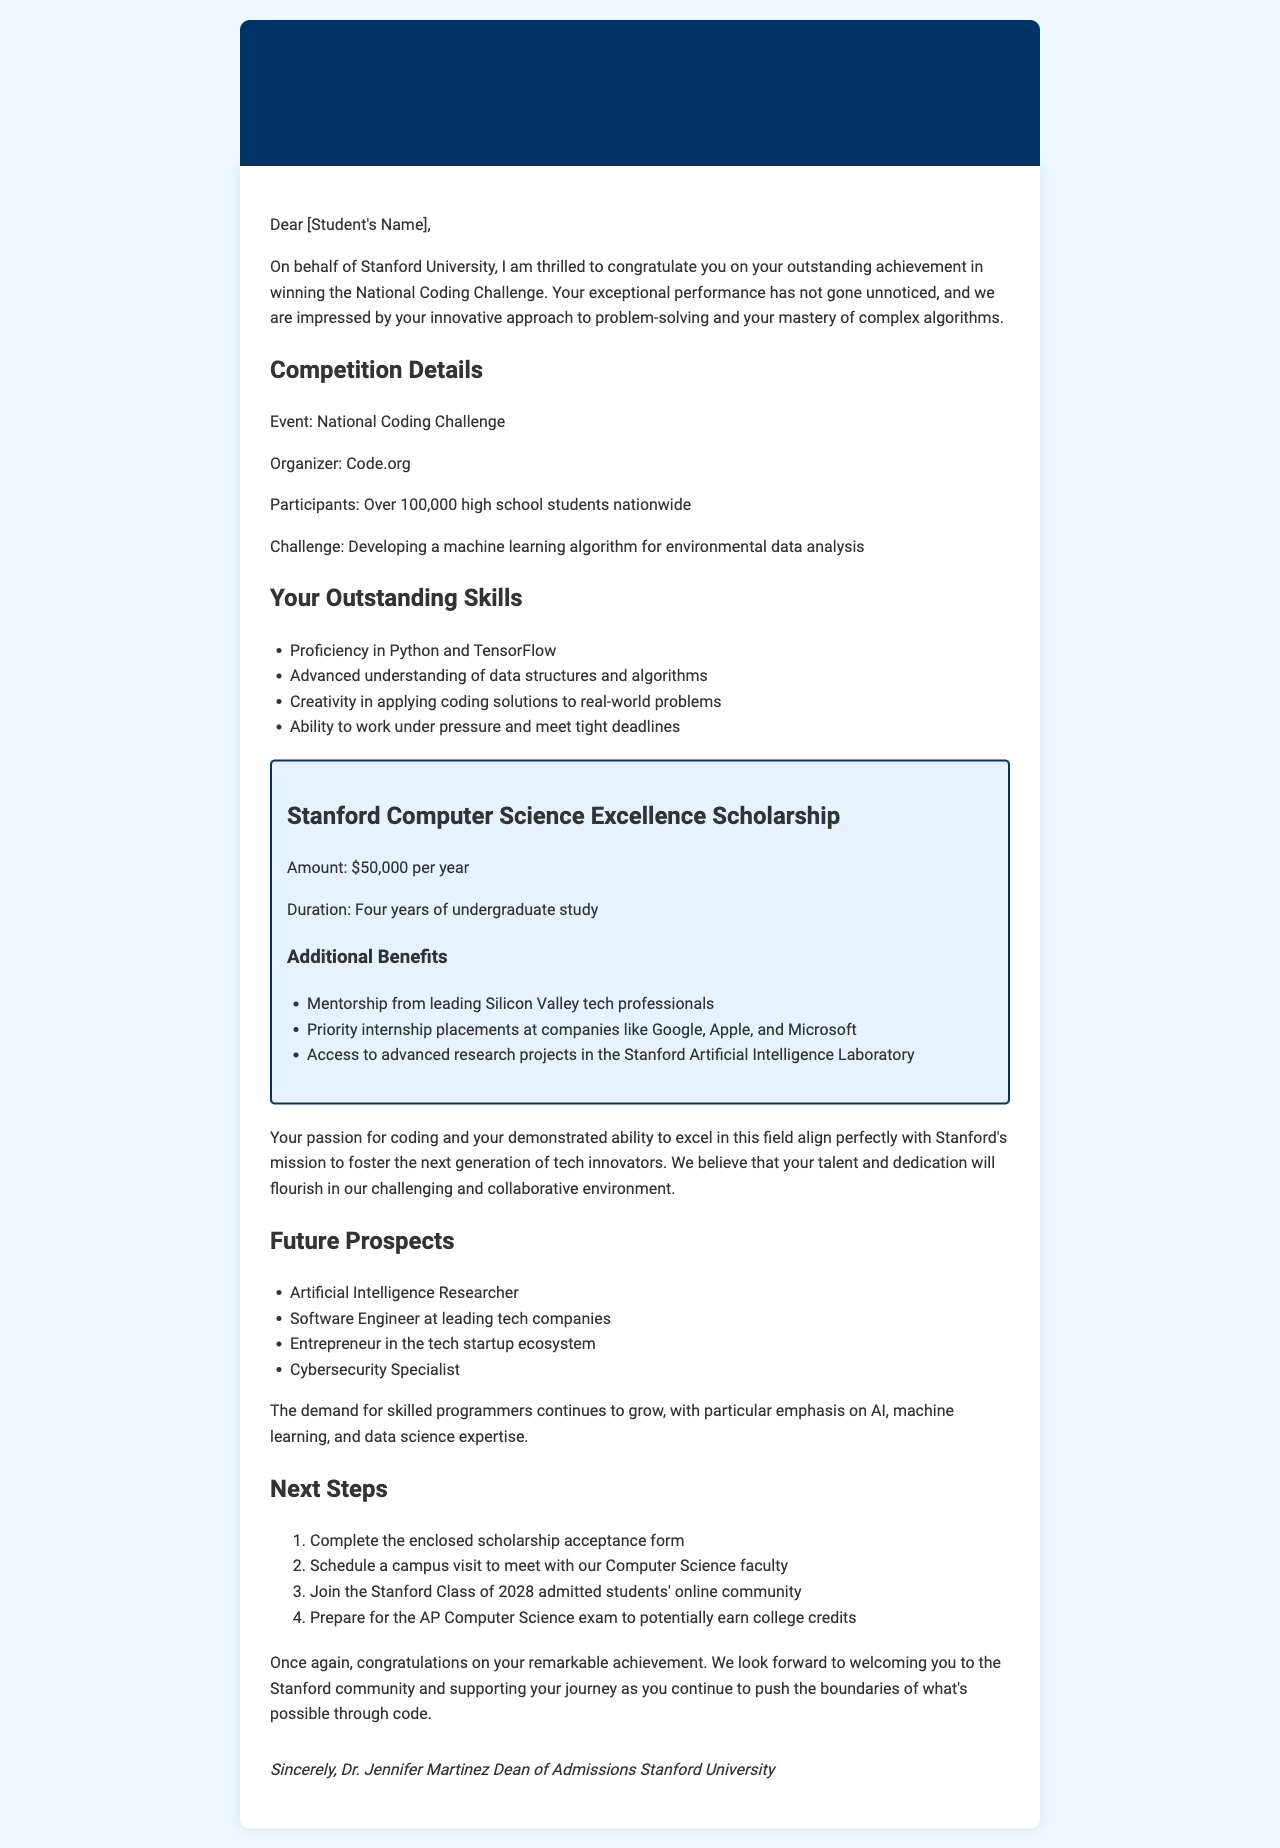What is the student's achievement? The student won the National Coding Challenge, a significant accomplishment in the field of coding and programming.
Answer: National Coding Challenge Who is the organizer of the competition? The document states that Code.org is the organizer for the National Coding Challenge.
Answer: Code.org What scholarship is offered to the student? The letter mentions a specific scholarship that is awarded to the student as part of the offer.
Answer: Stanford Computer Science Excellence Scholarship What is the scholarship amount per year? The document specifies the financial support offered to the student through the scholarship per academic year.
Answer: $50,000 How many years is the scholarship valid for? The duration of the scholarship mentioned in the letter indicates how long the awarded amount will be provided.
Answer: Four years What skill related to algorithms is highlighted? The letter notes the student's advanced understanding regarding a specific aspect of coding that is essential for problem-solving.
Answer: Advanced understanding of data structures and algorithms What is a potential career mentioned for the student? The document lists some future career paths the student may pursue that are related to coding and technology.
Answer: Artificial Intelligence Researcher What is one of the additional benefits of the scholarship? The letter outlines benefits included with the scholarship, providing the student with opportunities and resources.
Answer: Mentorship from leading Silicon Valley tech professionals What is the next step regarding the scholarship acceptance? The letter indicates a specific action the student must take in response to the scholarship offer.
Answer: Complete the enclosed scholarship acceptance form 